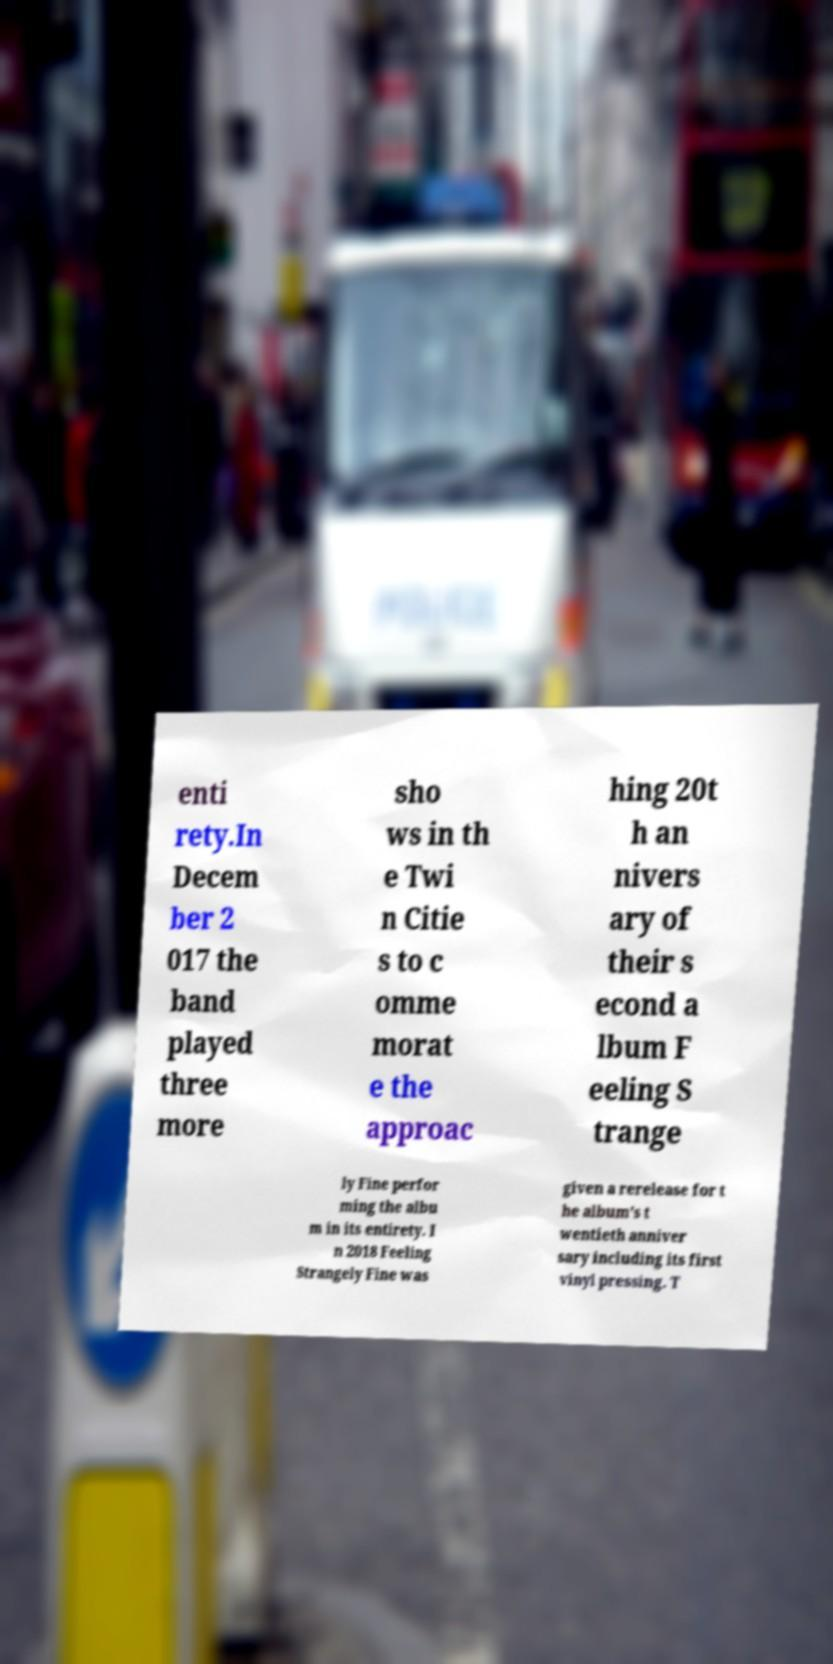For documentation purposes, I need the text within this image transcribed. Could you provide that? enti rety.In Decem ber 2 017 the band played three more sho ws in th e Twi n Citie s to c omme morat e the approac hing 20t h an nivers ary of their s econd a lbum F eeling S trange ly Fine perfor ming the albu m in its entirety. I n 2018 Feeling Strangely Fine was given a rerelease for t he album's t wentieth anniver sary including its first vinyl pressing. T 